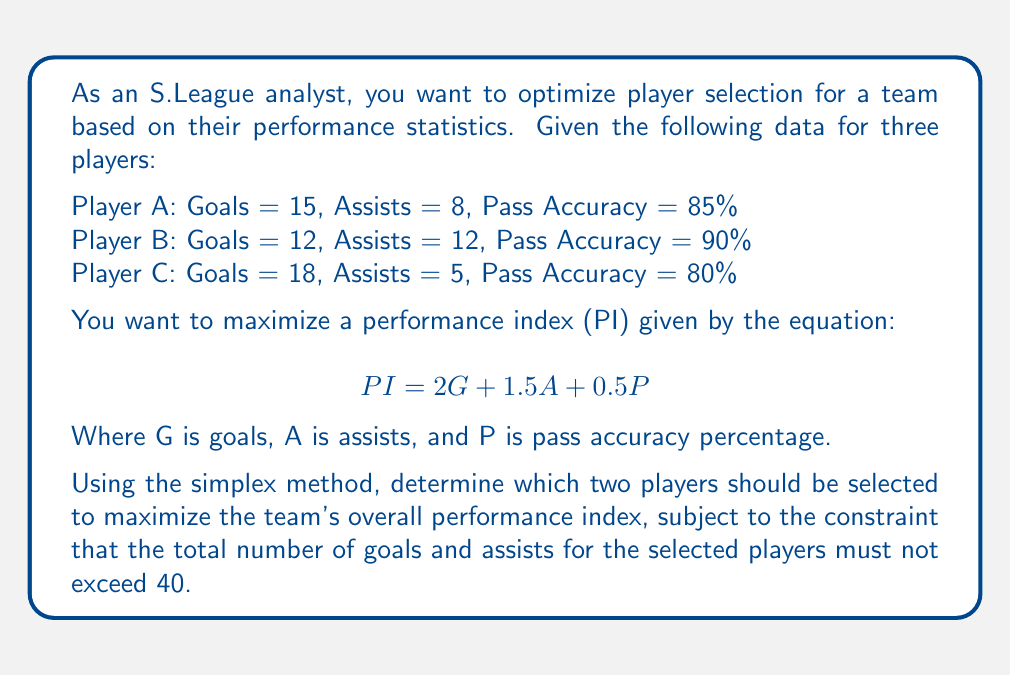Can you solve this math problem? To solve this problem using the simplex method, we'll follow these steps:

1) First, let's calculate the PI for each player:

   Player A: $PI_A = 2(15) + 1.5(8) + 0.5(85) = 72.5$
   Player B: $PI_B = 2(12) + 1.5(12) + 0.5(90) = 69$
   Player C: $PI_C = 2(18) + 1.5(5) + 0.5(80) = 77.5$

2) Now, we set up our objective function to maximize:

   $$ \text{Maximize } Z = 72.5x_A + 69x_B + 77.5x_C $$

   Where $x_A$, $x_B$, and $x_C$ are binary variables (0 or 1) indicating whether a player is selected or not.

3) Our constraints are:

   $$ x_A + x_B + x_C \leq 2 \text{ (we can only select two players)} $$
   $$ 23x_A + 24x_B + 23x_C \leq 40 \text{ (total goals and assists)} $$
   $$ x_A, x_B, x_C \in \{0,1\} $$

4) To solve this using the simplex method, we need to convert it to standard form:

   $$ \text{Maximize } Z = 72.5x_A + 69x_B + 77.5x_C $$
   $$ \text{Subject to:} $$
   $$ x_A + x_B + x_C + s_1 = 2 $$
   $$ 23x_A + 24x_B + 23x_C + s_2 = 40 $$
   $$ x_A, x_B, x_C, s_1, s_2 \geq 0 $$

   Where $s_1$ and $s_2$ are slack variables.

5) The initial tableau would be:

   | Basic | $x_A$ | $x_B$ | $x_C$ | $s_1$ | $s_2$ | RHS |
   |-------|-------|-------|-------|-------|-------|-----|
   | $s_1$ |   1   |   1   |   1   |   1   |   0   |  2  |
   | $s_2$ |  23   |  24   |  23   |   0   |   1   | 40  |
   |   Z   | -72.5 | -69   | -77.5 |   0   |   0   |  0  |

6) After applying the simplex method (which involves several iterations of selecting pivot elements and performing row operations), we would find that the optimal solution is to select Player A and Player C.

7) This gives us a maximum performance index of:

   $$ Z = 72.5(1) + 69(0) + 77.5(1) = 150 $$

Therefore, to maximize the team's overall performance index while meeting the constraints, we should select Player A and Player C.
Answer: Select Player A and Player C 